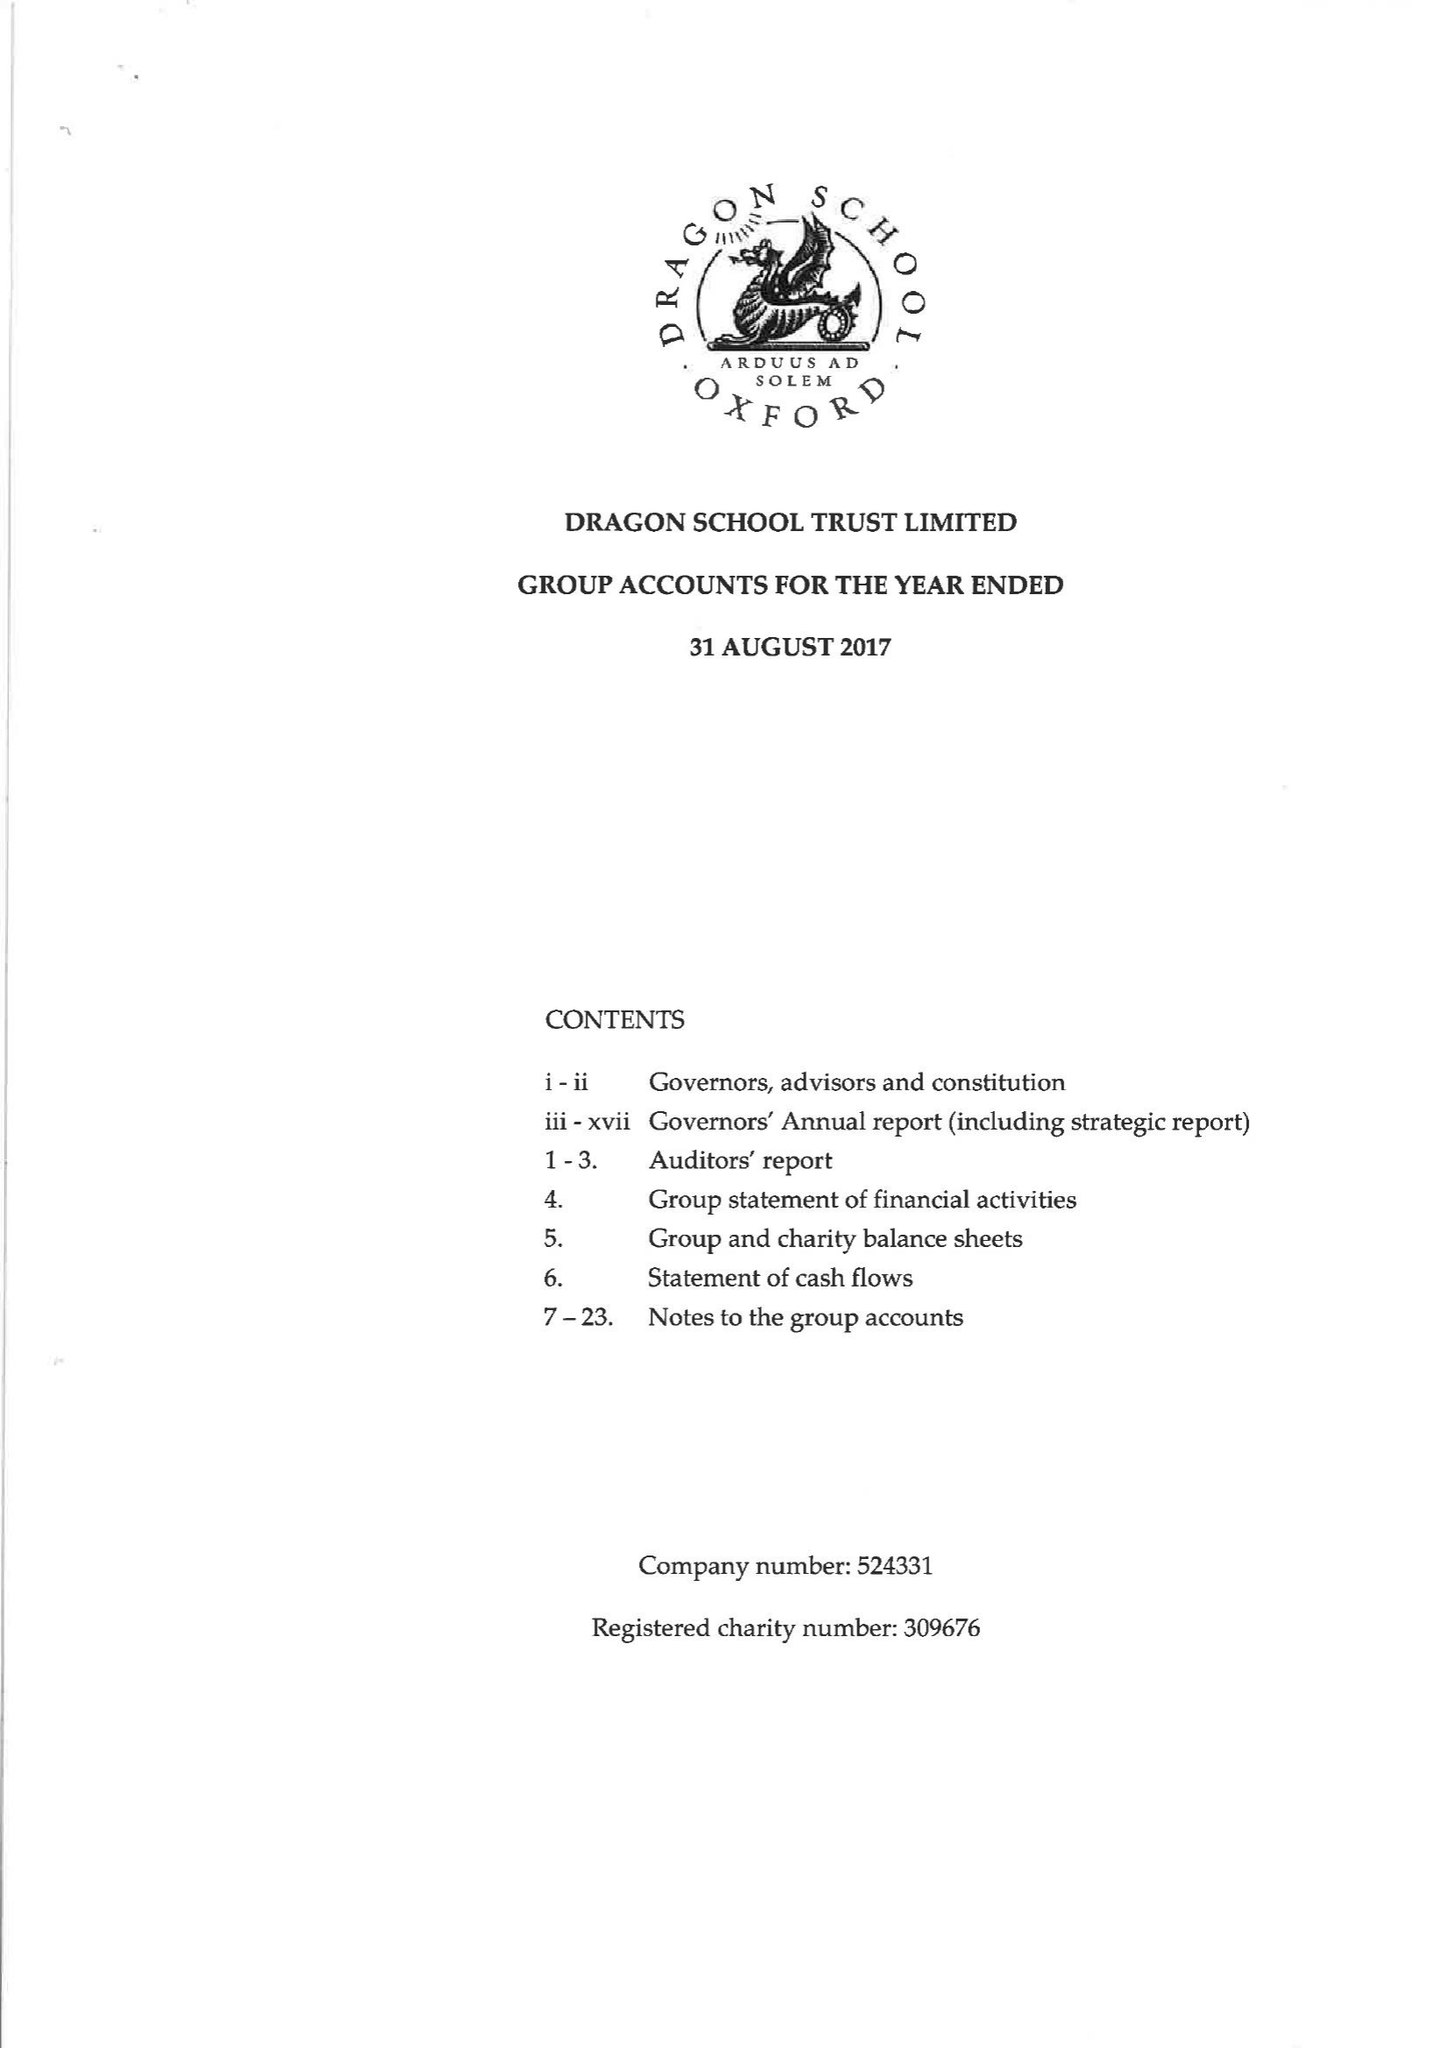What is the value for the charity_name?
Answer the question using a single word or phrase. Dragon School Trust Ltd. 